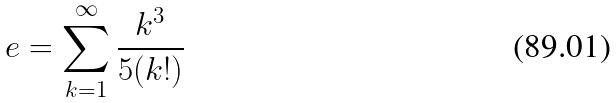<formula> <loc_0><loc_0><loc_500><loc_500>e = \sum _ { k = 1 } ^ { \infty } \frac { k ^ { 3 } } { 5 ( k ! ) }</formula> 